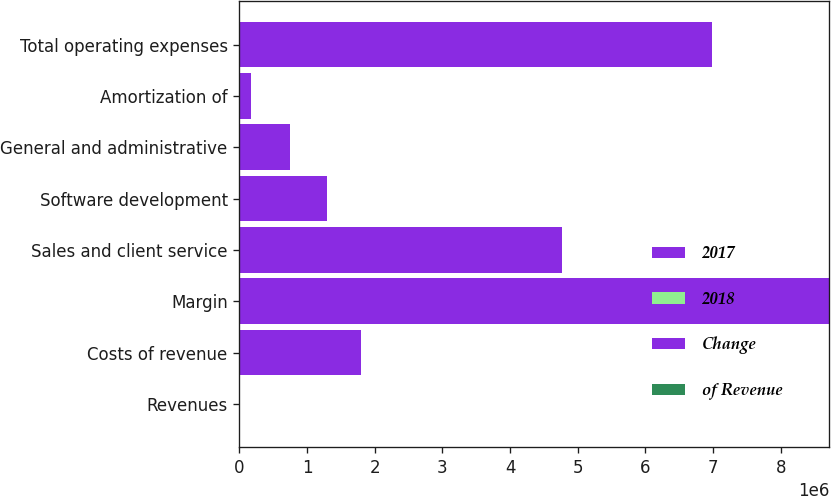Convert chart. <chart><loc_0><loc_0><loc_500><loc_500><stacked_bar_chart><ecel><fcel>Revenues<fcel>Costs of revenue<fcel>Margin<fcel>Sales and client service<fcel>Software development<fcel>General and administrative<fcel>Amortization of<fcel>Total operating expenses<nl><fcel>2017<fcel>91.5<fcel>937348<fcel>4.42898e+06<fcel>2.4937e+06<fcel>683663<fcel>389469<fcel>87364<fcel>3.65419e+06<nl><fcel>2018<fcel>100<fcel>17<fcel>83<fcel>46<fcel>13<fcel>7<fcel>2<fcel>68<nl><fcel>Change<fcel>91.5<fcel>854091<fcel>4.28818e+06<fcel>2.27682e+06<fcel>605046<fcel>355267<fcel>90576<fcel>3.32771e+06<nl><fcel>of Revenue<fcel>4<fcel>10<fcel>3<fcel>10<fcel>13<fcel>10<fcel>4<fcel>10<nl></chart> 